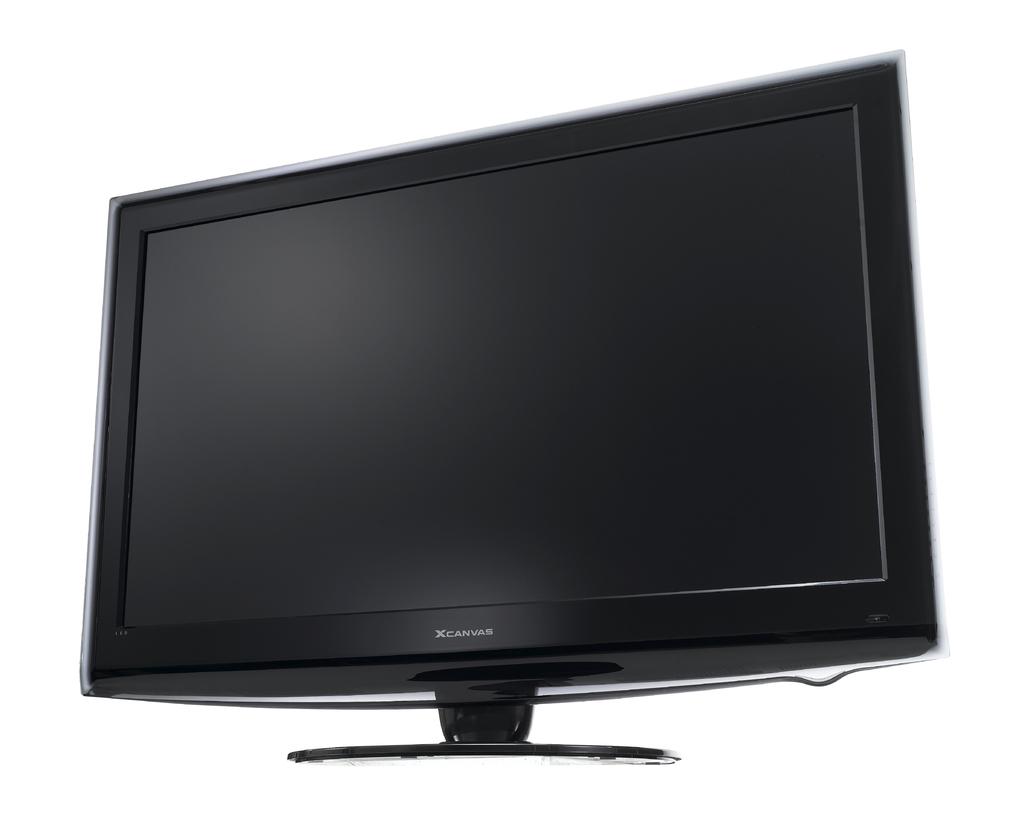Brand name dell?
Provide a succinct answer. No. 